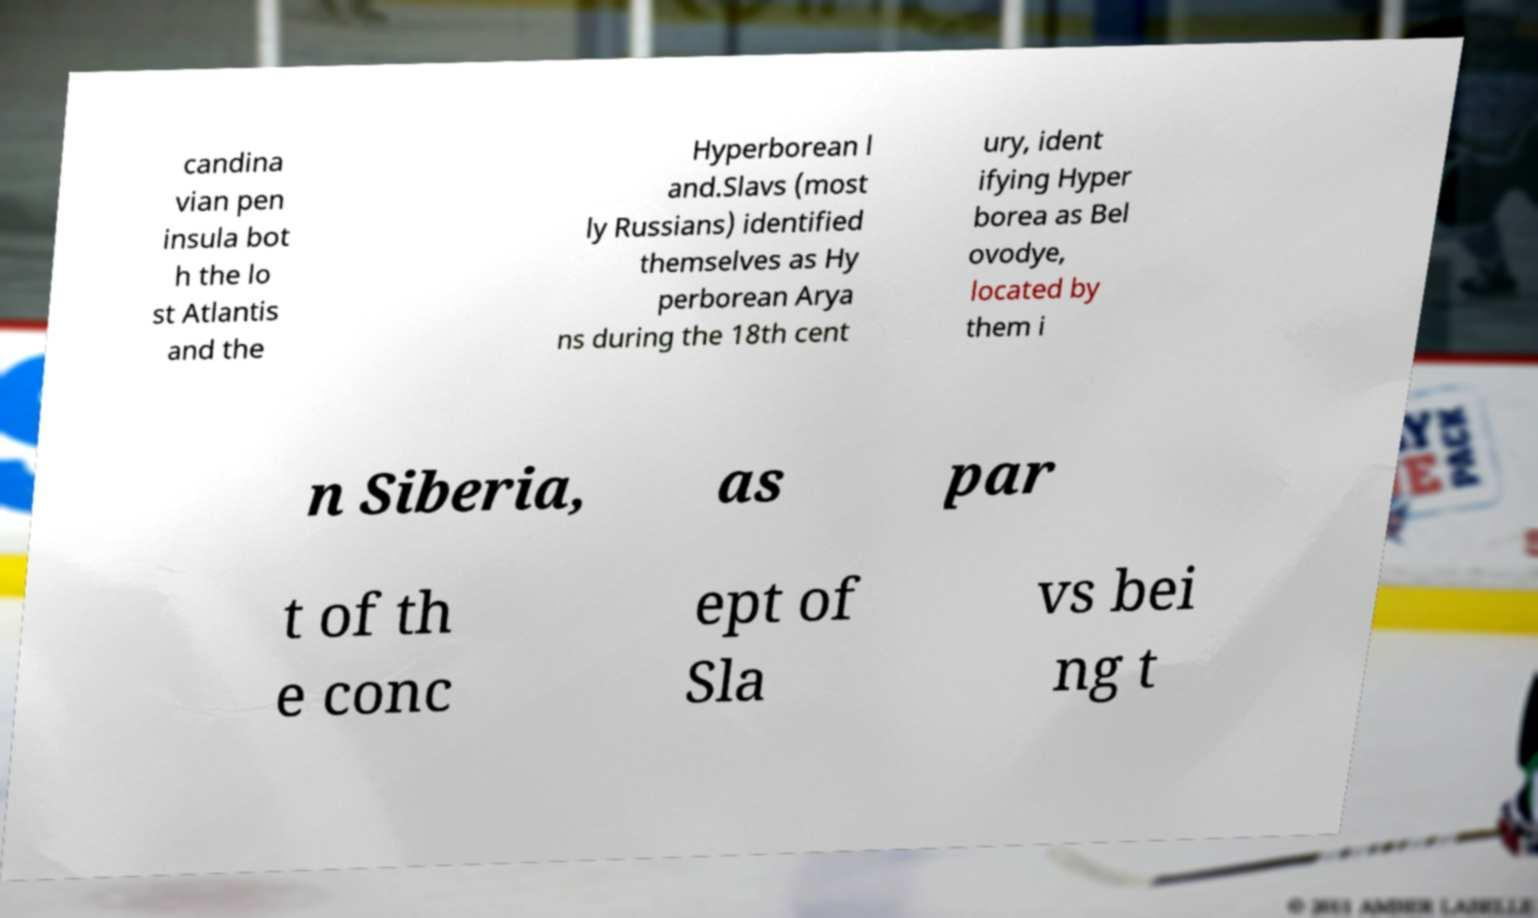For documentation purposes, I need the text within this image transcribed. Could you provide that? candina vian pen insula bot h the lo st Atlantis and the Hyperborean l and.Slavs (most ly Russians) identified themselves as Hy perborean Arya ns during the 18th cent ury, ident ifying Hyper borea as Bel ovodye, located by them i n Siberia, as par t of th e conc ept of Sla vs bei ng t 